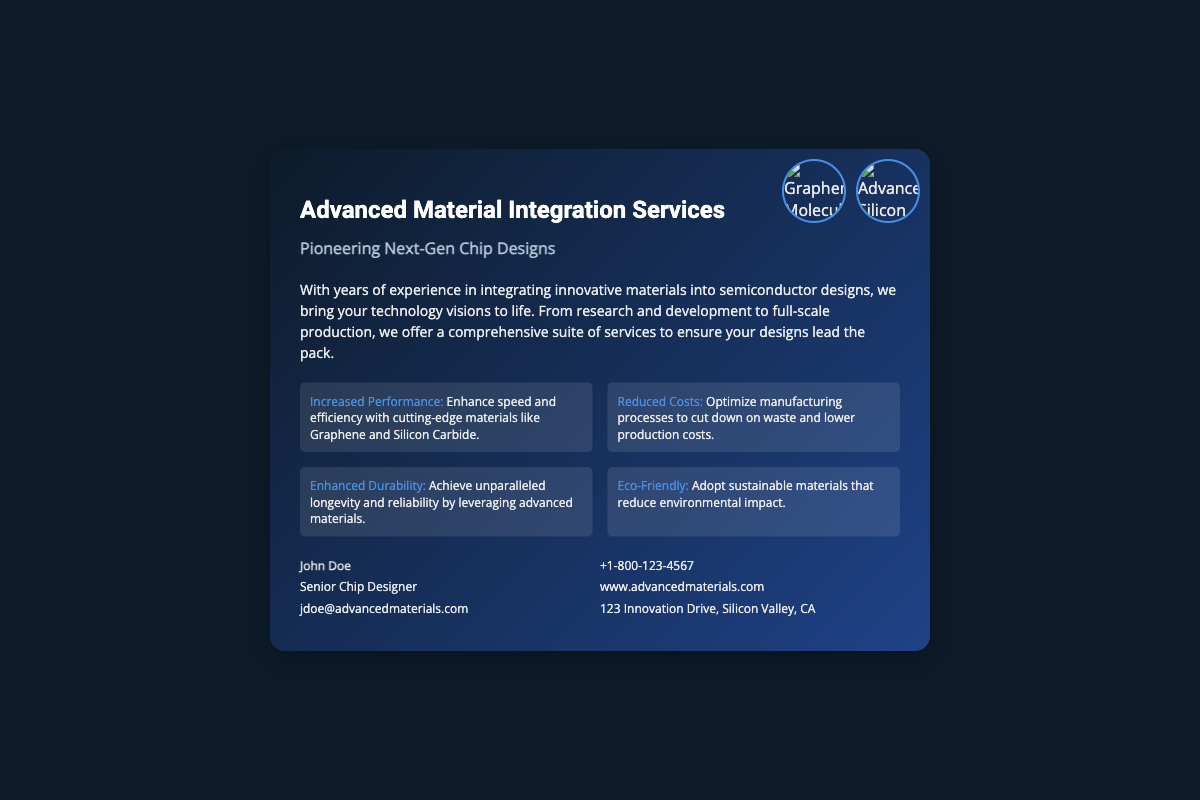What is the name of the service? The service is called "Advanced Material Integration Services," as stated in the title of the business card.
Answer: Advanced Material Integration Services Who is the contact person? The contact person listed on the business card is "John Doe."
Answer: John Doe What is one of the materials mentioned for increased performance? The materials mentioned for increased performance include "Graphene," as highlighted in the benefits section.
Answer: Graphene What is the contact email provided? The contact email for the service is listed as "jdoe@advancedmaterials.com."
Answer: jdoe@advancedmaterials.com How many benefits are listed in the document? There are four benefits outlined in the benefits section of the business card.
Answer: Four What is the address mentioned in the contact details? The address provided is "123 Innovation Drive, Silicon Valley, CA," as specified in the contact section.
Answer: 123 Innovation Drive, Silicon Valley, CA Which benefit highlights a focus on sustainability? The benefit that highlights sustainability is "Eco-Friendly," as stated in the benefits section.
Answer: Eco-Friendly What is the subtitle of the business card? The subtitle of the business card is "Pioneering Next-Gen Chip Designs," found just below the title.
Answer: Pioneering Next-Gen Chip Designs What is the phone number listed for contact? The phone number listed for contact is "+1-800-123-4567."
Answer: +1-800-123-4567 